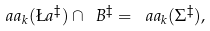<formula> <loc_0><loc_0><loc_500><loc_500>\ a a _ { k } ( \L a ^ { \ddag } ) \cap \ B ^ { \ddag } = \ a a _ { k } ( \Sigma ^ { \ddag } ) ,</formula> 